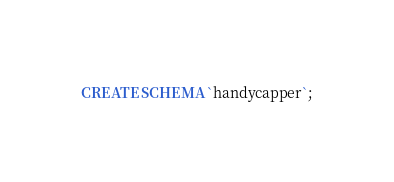<code> <loc_0><loc_0><loc_500><loc_500><_SQL_>CREATE SCHEMA `handycapper`;</code> 